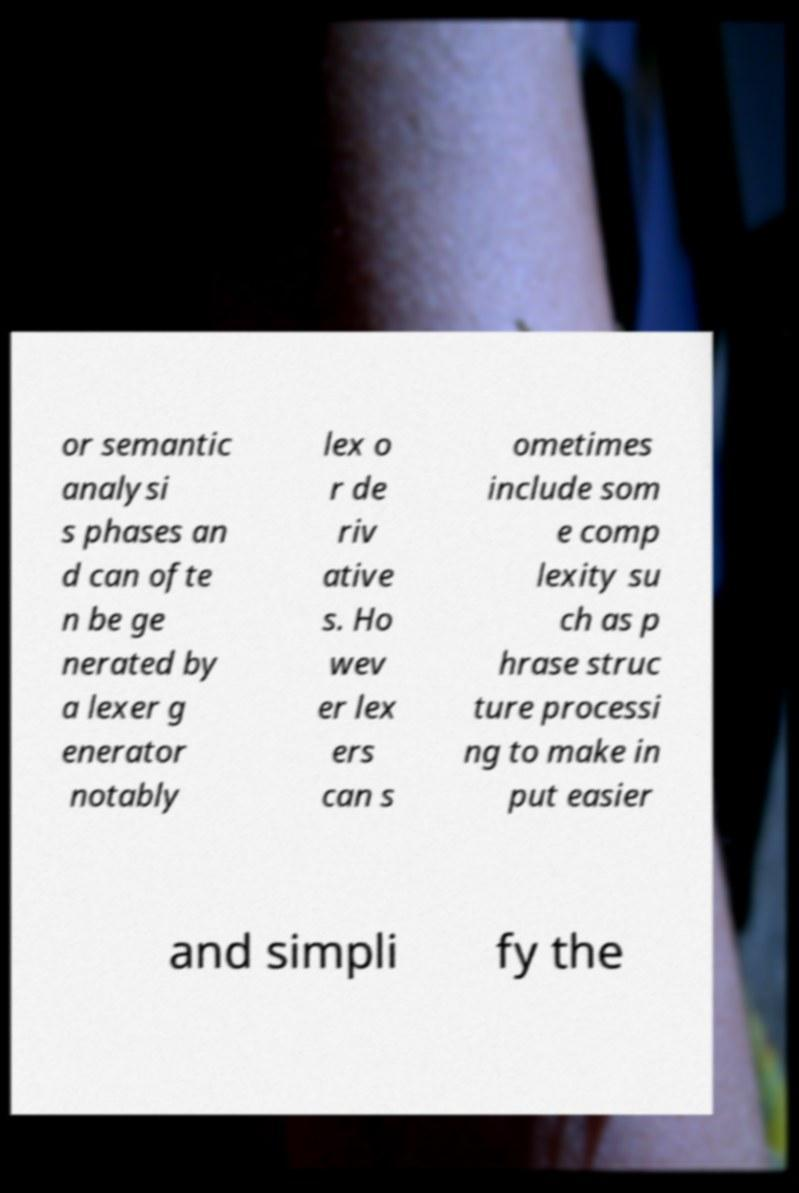I need the written content from this picture converted into text. Can you do that? or semantic analysi s phases an d can ofte n be ge nerated by a lexer g enerator notably lex o r de riv ative s. Ho wev er lex ers can s ometimes include som e comp lexity su ch as p hrase struc ture processi ng to make in put easier and simpli fy the 